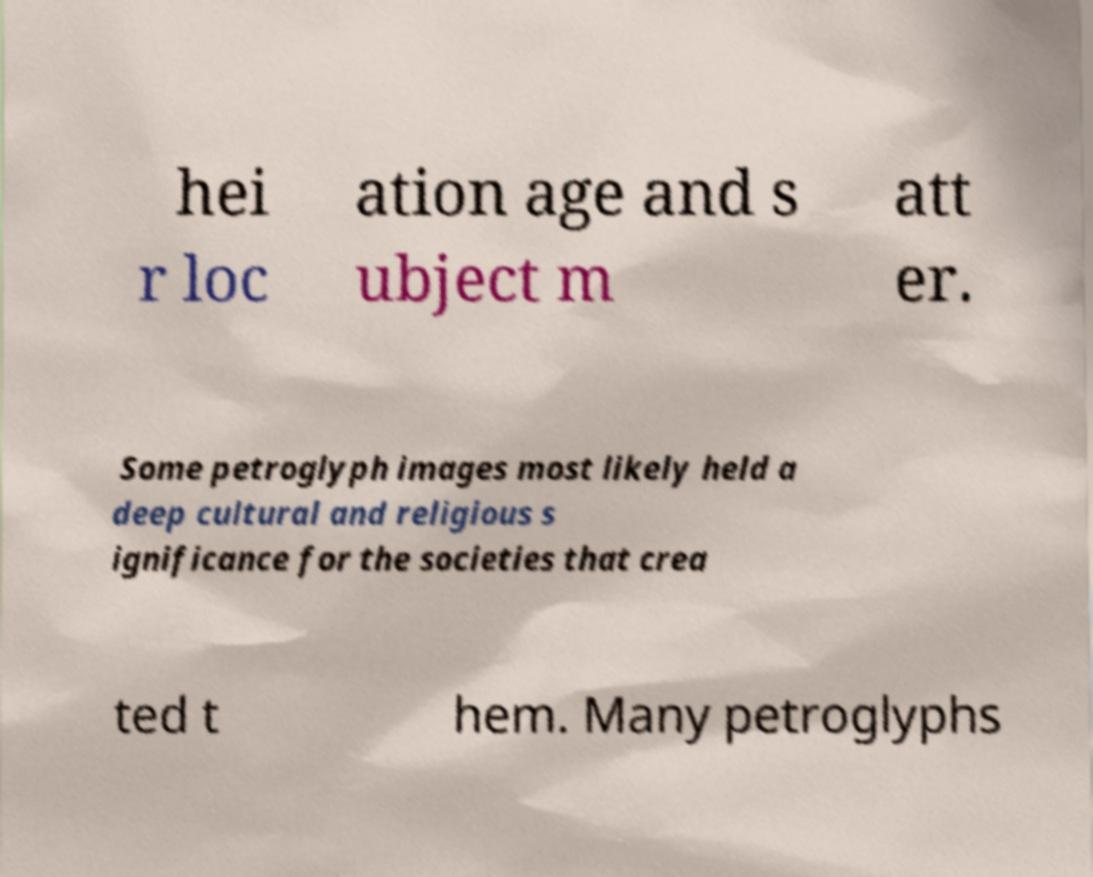Could you extract and type out the text from this image? hei r loc ation age and s ubject m att er. Some petroglyph images most likely held a deep cultural and religious s ignificance for the societies that crea ted t hem. Many petroglyphs 